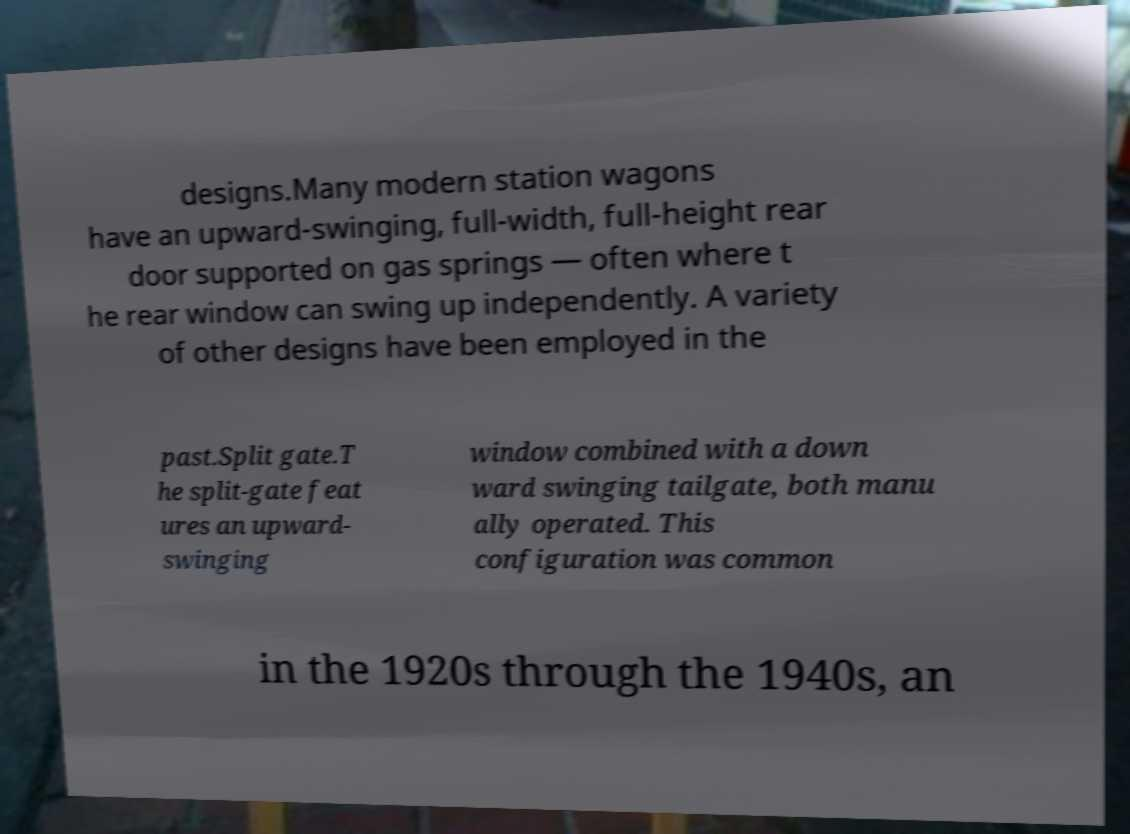For documentation purposes, I need the text within this image transcribed. Could you provide that? designs.Many modern station wagons have an upward-swinging, full-width, full-height rear door supported on gas springs — often where t he rear window can swing up independently. A variety of other designs have been employed in the past.Split gate.T he split-gate feat ures an upward- swinging window combined with a down ward swinging tailgate, both manu ally operated. This configuration was common in the 1920s through the 1940s, an 